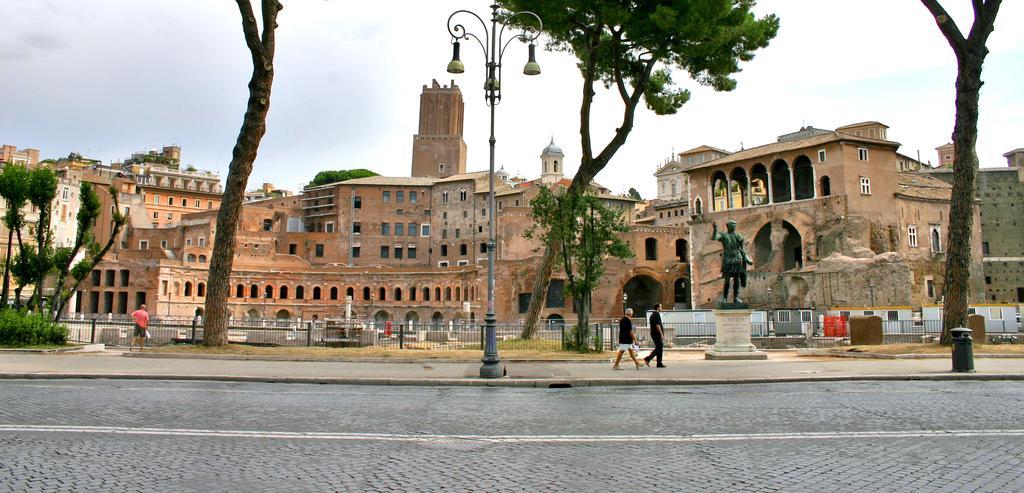Can you describe this image briefly? In this image we can see some buildings, trees, sculpture, people, fence, poles and other objects. In the background of the image there is the sky. At the bottom of the image there is the road. 